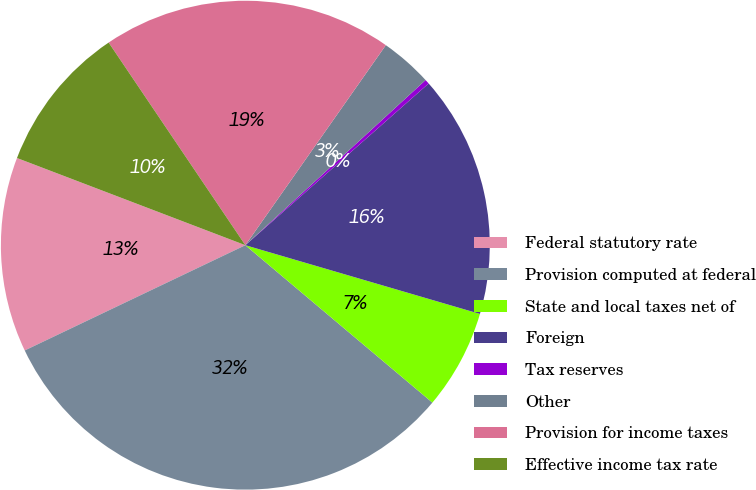Convert chart to OTSL. <chart><loc_0><loc_0><loc_500><loc_500><pie_chart><fcel>Federal statutory rate<fcel>Provision computed at federal<fcel>State and local taxes net of<fcel>Foreign<fcel>Tax reserves<fcel>Other<fcel>Provision for income taxes<fcel>Effective income tax rate<nl><fcel>12.89%<fcel>31.78%<fcel>6.6%<fcel>16.04%<fcel>0.3%<fcel>3.45%<fcel>19.19%<fcel>9.75%<nl></chart> 